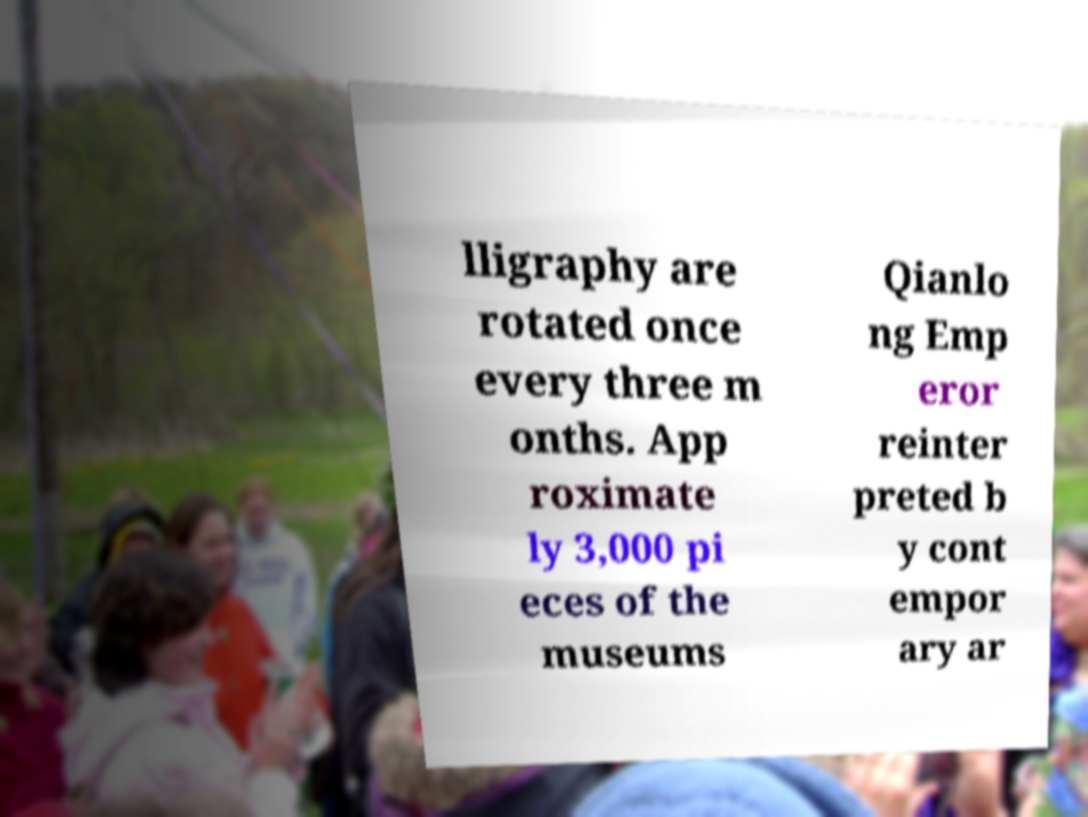Could you extract and type out the text from this image? lligraphy are rotated once every three m onths. App roximate ly 3,000 pi eces of the museums Qianlo ng Emp eror reinter preted b y cont empor ary ar 